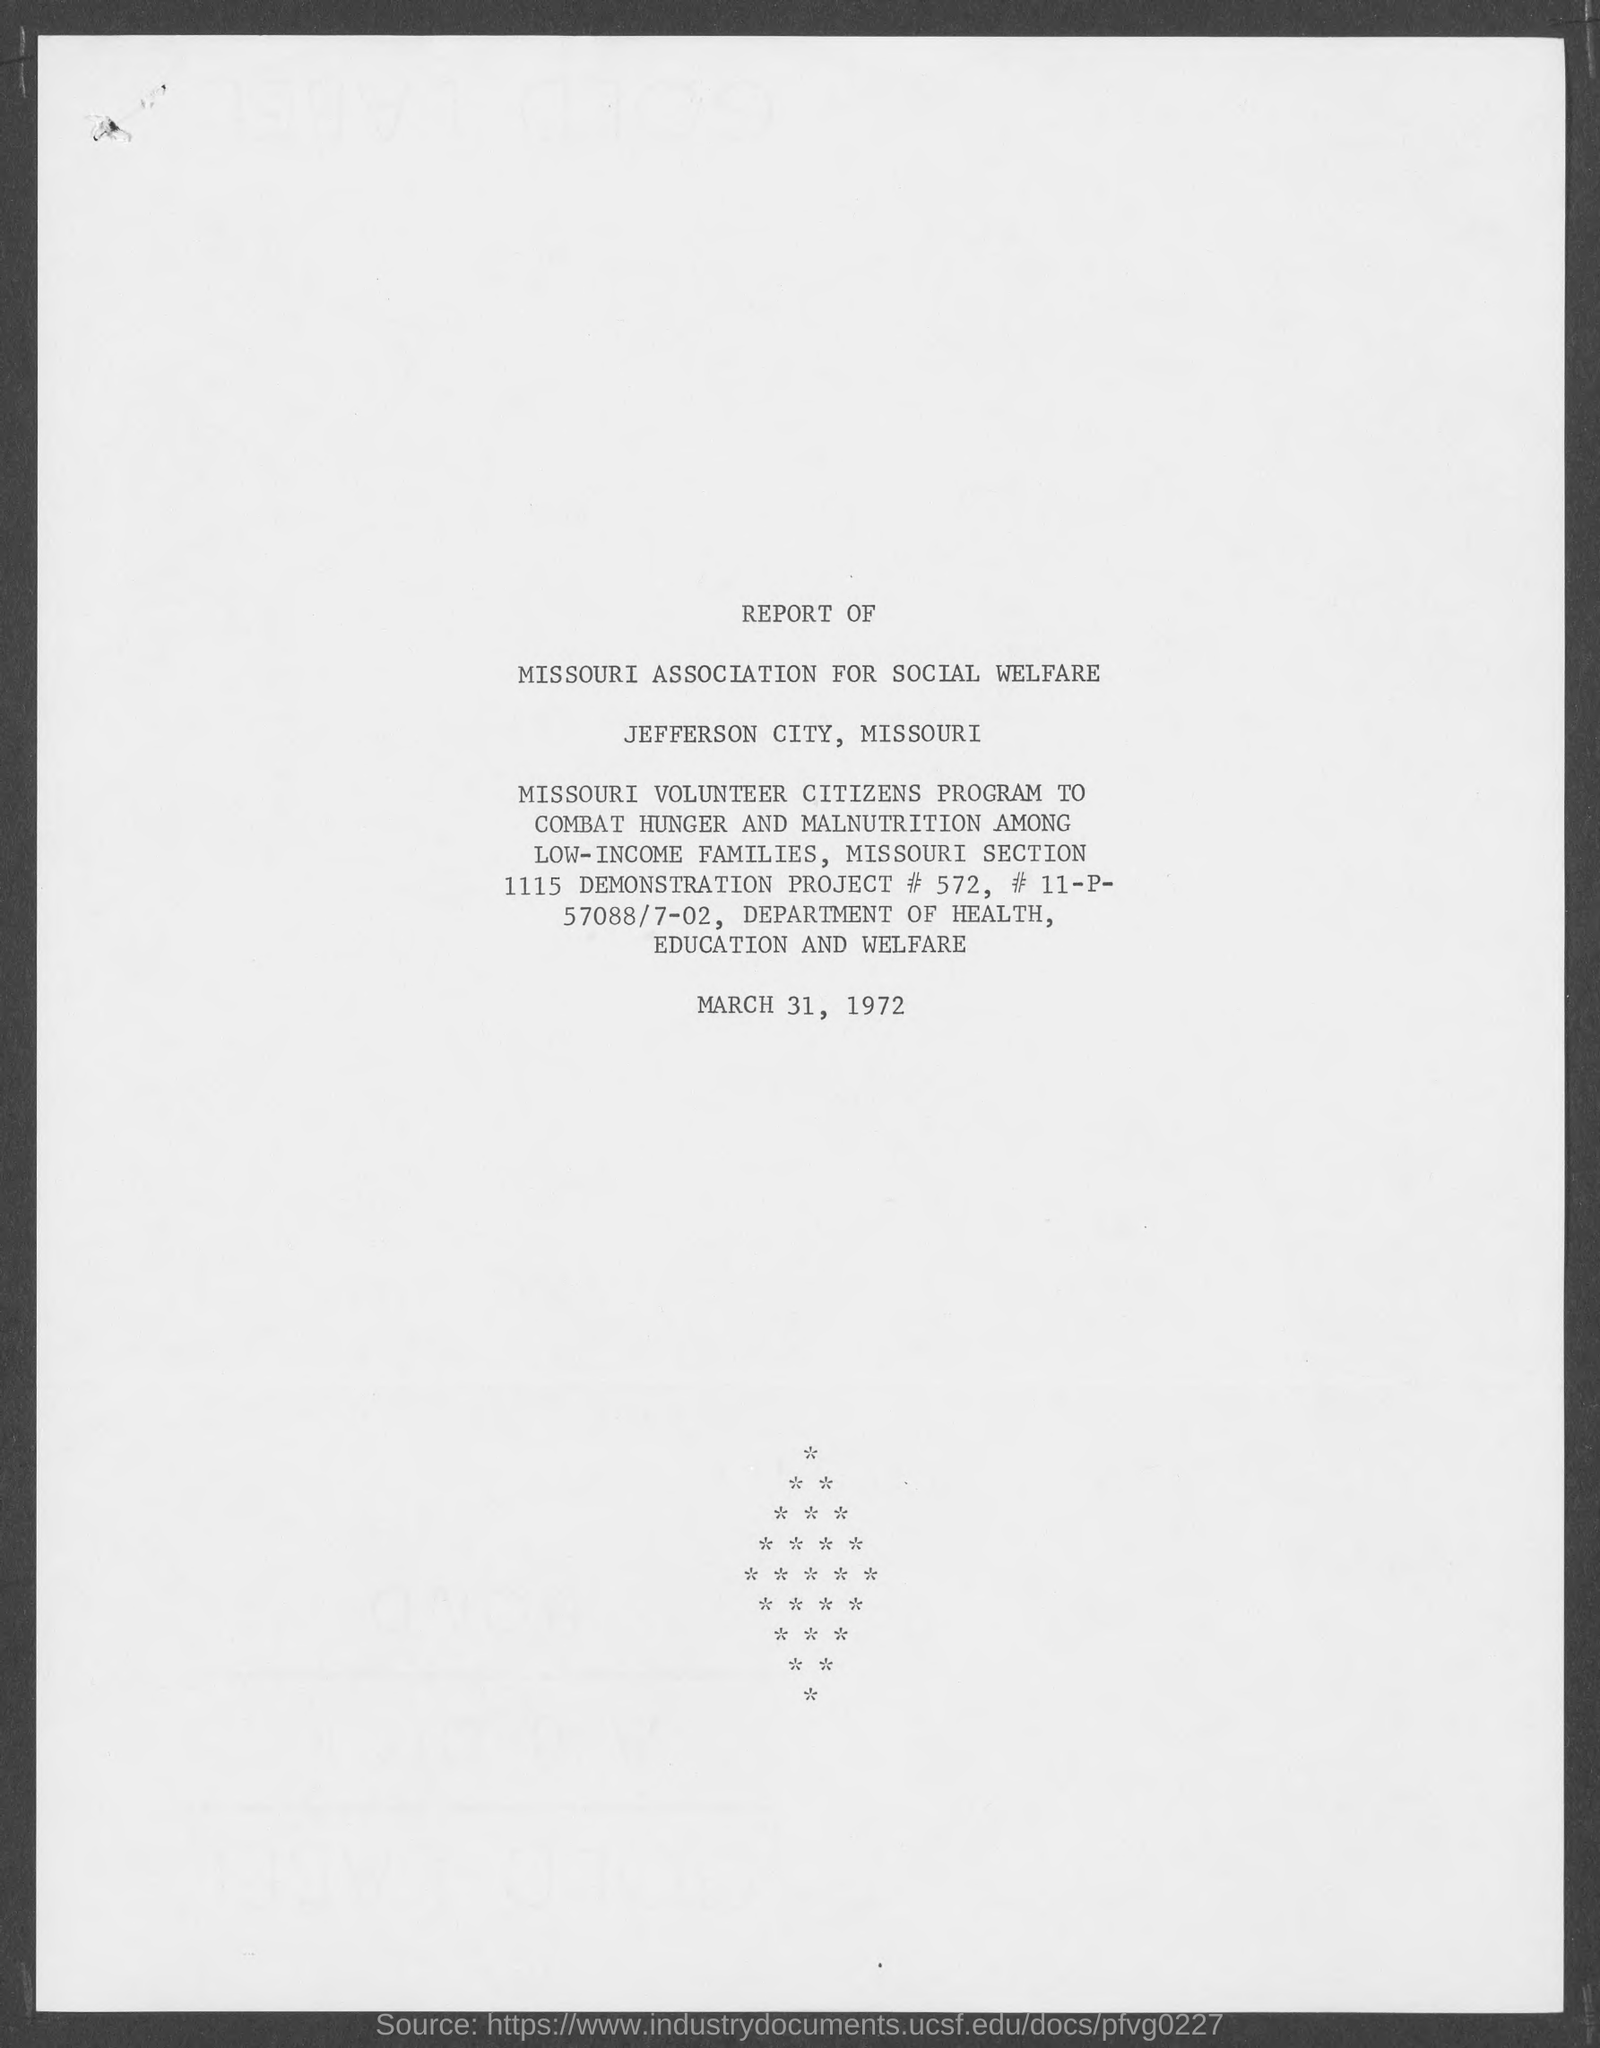Give some essential details in this illustration. The location of the "MISSOURI ASSOCIATION FOR SOCIAL WELFARE" is Jefferson City, Missouri. The date given at the end of the report is March 31, 1972. 